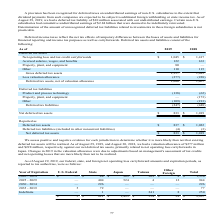According to Micron Technology's financial document, What do the deferred income taxes reflect? the net tax effects of temporary differences between the bases of assets and liabilities for financial reporting and income tax purposes as well as carryforwards. The document states: "Deferred income taxes reflect the net tax effects of temporary differences between the bases of assets and liabilities for financial reporting and inc..." Also, What caused the change in valuation allowance in 2019? adjustments based on management's assessment of tax credits and net operating losses that are more likely than not to be realized. The document states: "es in 2019 in the valuation allowance were due to adjustments based on management's assessment of tax credits and net operating losses that are more l..." Also, What is the amount of net deferred tax assets in 2018? According to the financial document, $1,019 (in millions). The relevant text states: "Net deferred tax assets $ 833 $ 1,019..." Also, can you calculate: What is the percentage change in the amount of net deferred tax assets from 2018 to 2019? To answer this question, I need to perform calculations using the financial data. The calculation is: ($833-$1,019)/1,019 , which equals -18.25 (percentage). This is based on the information: "Net deferred tax assets $ 833 $ 1,019 Net deferred tax assets $ 833 $ 1,019..." The key data points involved are: 1,019, 833. Also, can you calculate: What is the difference between the amount of gross deferred tax assets in 2018 and 2019? Based on the calculation: 1,695-1,357 , the result is 338 (in millions). This is based on the information: "Gross deferred tax assets 1,357 1,695 Gross deferred tax assets 1,357 1,695..." The key data points involved are: 1,357, 1,695. Also, can you calculate: What is the ratio of the amount of net deferred tax liabilities in 2018 over 2019? To answer this question, I need to perform calculations using the financial data. The calculation is: -448/-247 , which equals 1.81. This is based on the information: "Deferred tax liabilities (247) (448) Deferred tax liabilities (247) (448)..." The key data points involved are: 247, 448. 